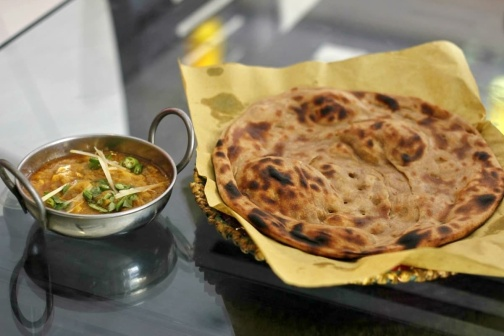What ingredients can you identify in the curry dish? The curry appears to be richly spiced and garnished. From the visual cues, it likely contains ingredients such as onions, tomatoes, green herbs like coriander, sliced green chilies, and possibly slices of ginger on top. The sauce hints at a blend of spices, which could include turmeric, cumin, and coriander, giving it a deep, vibrant color. Can you describe the taste and texture of the flatbread? The flatbread, with its crisp, charred spots, suggests a chewy and slightly crunchy texture on the outside, while being soft and fluffy on the inside. The taste is likely reminiscent of freshly baked bread, with a hint of smokiness from the charred spots. Imagine the curry has a secret ingredient that changes color when you eat it. What would it be and how would it look? Imagine the curry’s secret ingredient is a type of edible flower that imparts a dazzling effect. As you take a bite, the curry tingles with a soft glow. The flower’s essence activates upon contact with the palate, causing streaks of iridescent color to swirl through the curry, transforming it into a mesmerizing, shimmering display of blues, purples, and golds. 